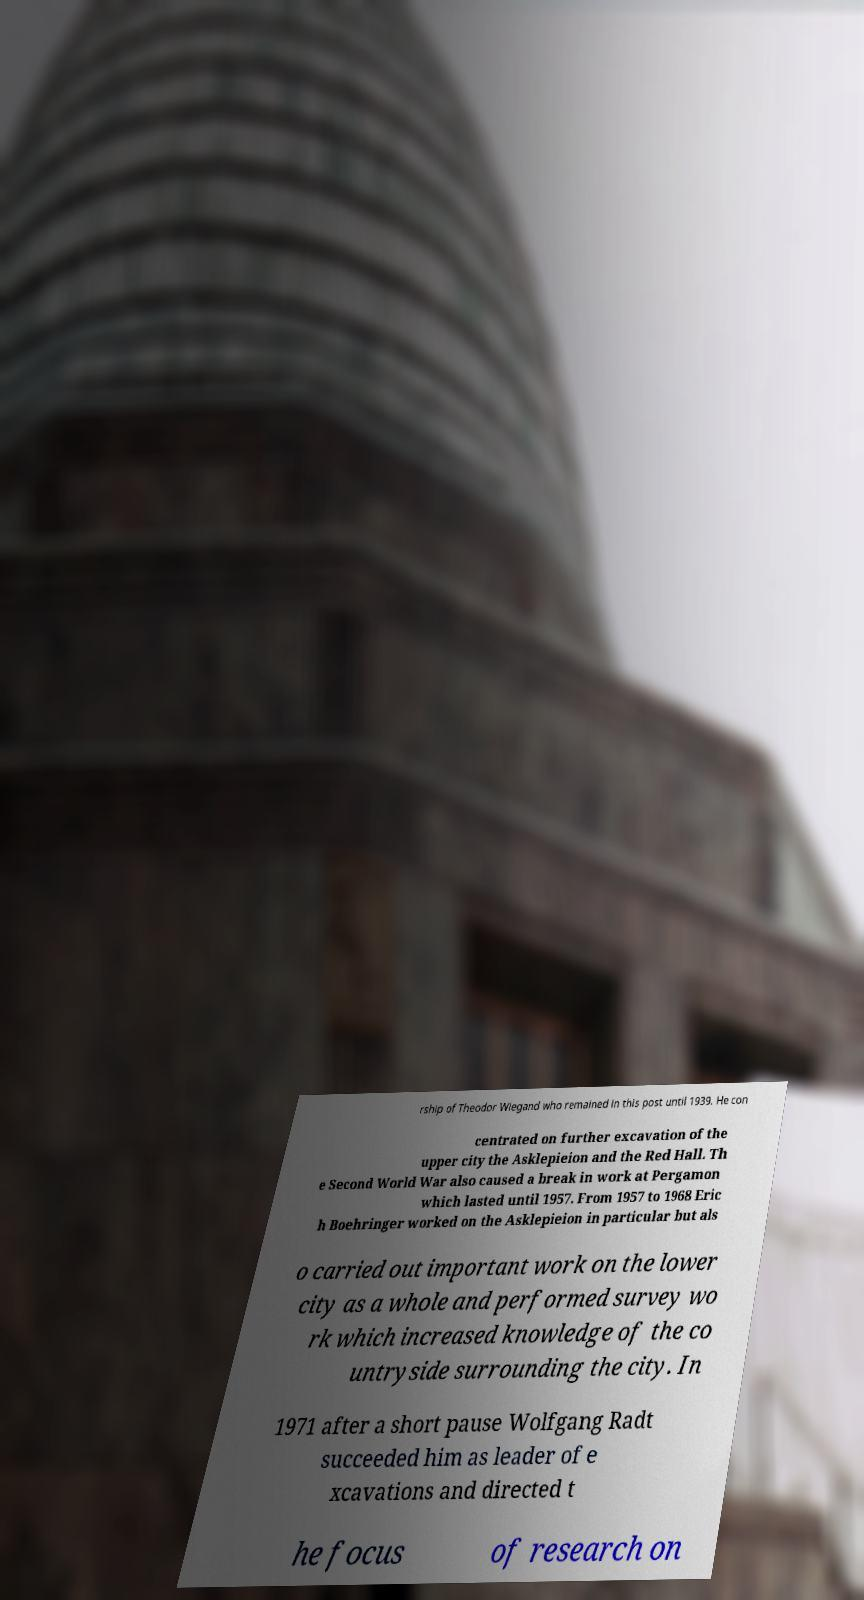I need the written content from this picture converted into text. Can you do that? rship of Theodor Wiegand who remained in this post until 1939. He con centrated on further excavation of the upper city the Asklepieion and the Red Hall. Th e Second World War also caused a break in work at Pergamon which lasted until 1957. From 1957 to 1968 Eric h Boehringer worked on the Asklepieion in particular but als o carried out important work on the lower city as a whole and performed survey wo rk which increased knowledge of the co untryside surrounding the city. In 1971 after a short pause Wolfgang Radt succeeded him as leader of e xcavations and directed t he focus of research on 